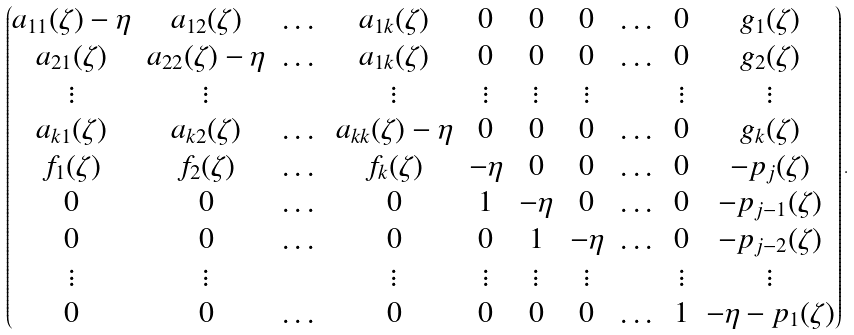Convert formula to latex. <formula><loc_0><loc_0><loc_500><loc_500>\begin{pmatrix} a _ { 1 1 } ( \zeta ) - \eta & a _ { 1 2 } ( \zeta ) & \dots & a _ { 1 k } ( \zeta ) & 0 & 0 & 0 & \dots & 0 & g _ { 1 } ( \zeta ) \\ a _ { 2 1 } ( \zeta ) & a _ { 2 2 } ( \zeta ) - \eta & \dots & a _ { 1 k } ( \zeta ) & 0 & 0 & 0 & \dots & 0 & g _ { 2 } ( \zeta ) \\ \vdots & \vdots & & \vdots & \vdots & \vdots & \vdots & & \vdots & \vdots \\ a _ { k 1 } ( \zeta ) & a _ { k 2 } ( \zeta ) & \dots & a _ { k k } ( \zeta ) - \eta & 0 & 0 & 0 & \dots & 0 & g _ { k } ( \zeta ) \\ f _ { 1 } ( \zeta ) & f _ { 2 } ( \zeta ) & \dots & f _ { k } ( \zeta ) & - \eta & 0 & 0 & \dots & 0 & - p _ { j } ( \zeta ) \\ 0 & 0 & \dots & 0 & 1 & - \eta & 0 & \dots & 0 & - p _ { j - 1 } ( \zeta ) \\ 0 & 0 & \dots & 0 & 0 & 1 & - \eta & \dots & 0 & - p _ { j - 2 } ( \zeta ) \\ \vdots & \vdots & & \vdots & \vdots & \vdots & \vdots & & \vdots & \vdots \\ 0 & 0 & \dots & 0 & 0 & 0 & 0 & \dots & 1 & - \eta - p _ { 1 } ( \zeta ) \end{pmatrix} .</formula> 